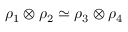<formula> <loc_0><loc_0><loc_500><loc_500>\rho _ { 1 } \otimes \rho _ { 2 } \simeq \rho _ { 3 } \otimes \rho _ { 4 }</formula> 